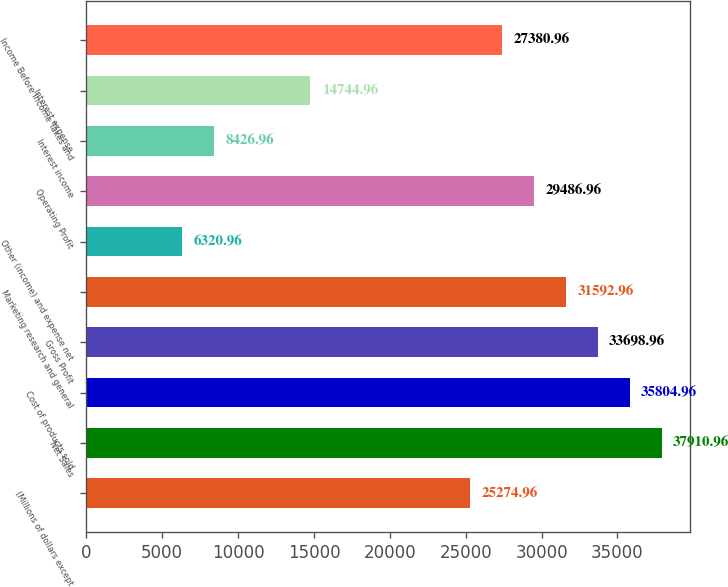<chart> <loc_0><loc_0><loc_500><loc_500><bar_chart><fcel>(Millions of dollars except<fcel>Net Sales<fcel>Cost of products sold<fcel>Gross Profit<fcel>Marketing research and general<fcel>Other (income) and expense net<fcel>Operating Profit<fcel>Interest income<fcel>Interest expense<fcel>Income Before Income Taxes and<nl><fcel>25275<fcel>37911<fcel>35805<fcel>33699<fcel>31593<fcel>6320.96<fcel>29487<fcel>8426.96<fcel>14745<fcel>27381<nl></chart> 